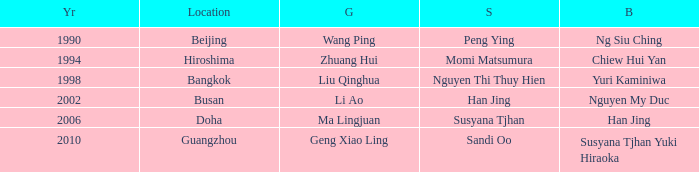What's the Bronze with the Year of 1998? Yuri Kaminiwa. 